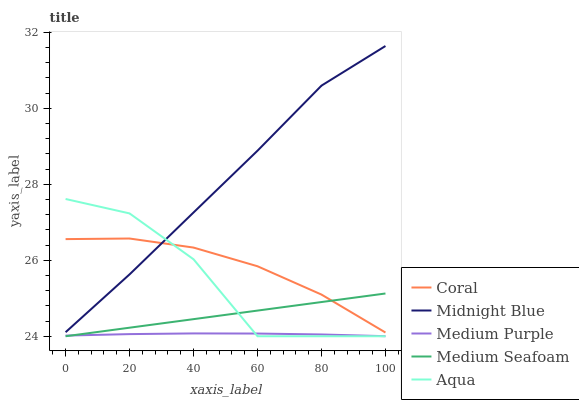Does Coral have the minimum area under the curve?
Answer yes or no. No. Does Coral have the maximum area under the curve?
Answer yes or no. No. Is Coral the smoothest?
Answer yes or no. No. Is Coral the roughest?
Answer yes or no. No. Does Coral have the lowest value?
Answer yes or no. No. Does Coral have the highest value?
Answer yes or no. No. Is Medium Seafoam less than Midnight Blue?
Answer yes or no. Yes. Is Midnight Blue greater than Medium Seafoam?
Answer yes or no. Yes. Does Medium Seafoam intersect Midnight Blue?
Answer yes or no. No. 